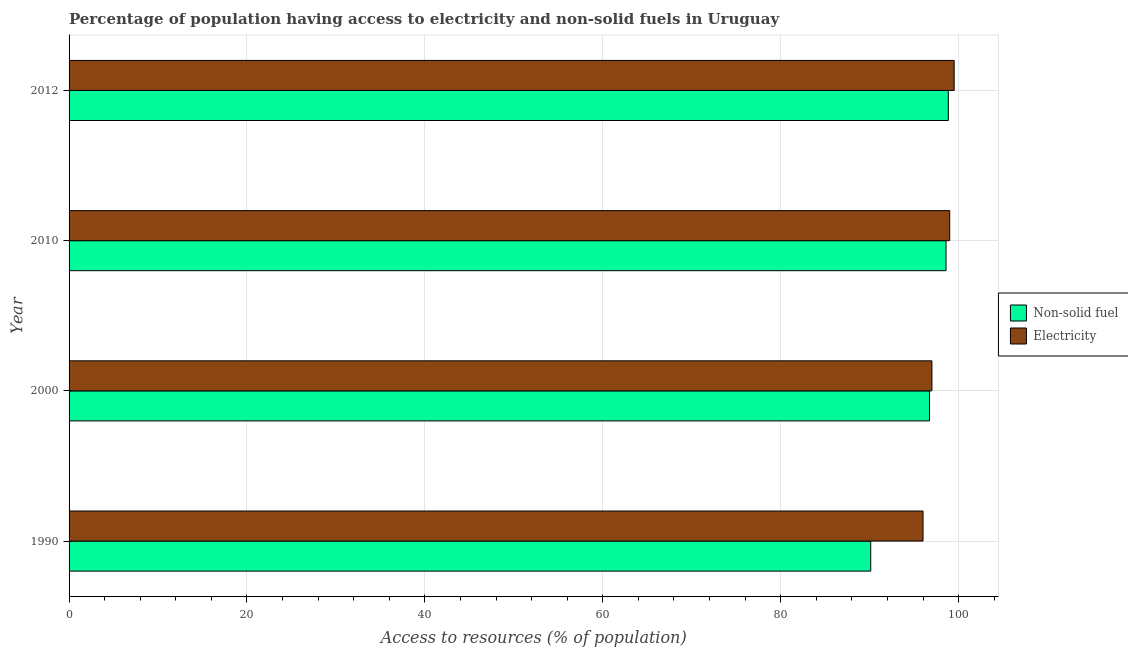How many groups of bars are there?
Ensure brevity in your answer.  4. How many bars are there on the 3rd tick from the top?
Provide a succinct answer. 2. What is the label of the 4th group of bars from the top?
Your response must be concise. 1990. What is the percentage of population having access to non-solid fuel in 2010?
Your answer should be compact. 98.59. Across all years, what is the maximum percentage of population having access to electricity?
Offer a terse response. 99.5. Across all years, what is the minimum percentage of population having access to electricity?
Keep it short and to the point. 96. In which year was the percentage of population having access to electricity minimum?
Give a very brief answer. 1990. What is the total percentage of population having access to non-solid fuel in the graph?
Provide a short and direct response. 384.29. What is the difference between the percentage of population having access to electricity in 1990 and that in 2012?
Make the answer very short. -3.5. What is the difference between the percentage of population having access to electricity in 2000 and the percentage of population having access to non-solid fuel in 2010?
Provide a succinct answer. -1.59. What is the average percentage of population having access to electricity per year?
Offer a very short reply. 97.88. In the year 2010, what is the difference between the percentage of population having access to non-solid fuel and percentage of population having access to electricity?
Ensure brevity in your answer.  -0.41. Is the difference between the percentage of population having access to non-solid fuel in 2000 and 2010 greater than the difference between the percentage of population having access to electricity in 2000 and 2010?
Offer a very short reply. Yes. What is the difference between the highest and the second highest percentage of population having access to non-solid fuel?
Ensure brevity in your answer.  0.26. What is the difference between the highest and the lowest percentage of population having access to non-solid fuel?
Keep it short and to the point. 8.72. Is the sum of the percentage of population having access to electricity in 2000 and 2010 greater than the maximum percentage of population having access to non-solid fuel across all years?
Keep it short and to the point. Yes. What does the 2nd bar from the top in 2010 represents?
Provide a short and direct response. Non-solid fuel. What does the 2nd bar from the bottom in 2010 represents?
Make the answer very short. Electricity. How many bars are there?
Give a very brief answer. 8. How many years are there in the graph?
Offer a very short reply. 4. Where does the legend appear in the graph?
Keep it short and to the point. Center right. How many legend labels are there?
Your response must be concise. 2. How are the legend labels stacked?
Your answer should be very brief. Vertical. What is the title of the graph?
Your answer should be very brief. Percentage of population having access to electricity and non-solid fuels in Uruguay. What is the label or title of the X-axis?
Your answer should be very brief. Access to resources (% of population). What is the Access to resources (% of population) of Non-solid fuel in 1990?
Provide a succinct answer. 90.12. What is the Access to resources (% of population) in Electricity in 1990?
Your answer should be compact. 96. What is the Access to resources (% of population) of Non-solid fuel in 2000?
Offer a very short reply. 96.73. What is the Access to resources (% of population) of Electricity in 2000?
Offer a very short reply. 97. What is the Access to resources (% of population) of Non-solid fuel in 2010?
Offer a terse response. 98.59. What is the Access to resources (% of population) in Electricity in 2010?
Your answer should be very brief. 99. What is the Access to resources (% of population) in Non-solid fuel in 2012?
Give a very brief answer. 98.85. What is the Access to resources (% of population) of Electricity in 2012?
Your answer should be compact. 99.5. Across all years, what is the maximum Access to resources (% of population) in Non-solid fuel?
Your answer should be compact. 98.85. Across all years, what is the maximum Access to resources (% of population) in Electricity?
Ensure brevity in your answer.  99.5. Across all years, what is the minimum Access to resources (% of population) in Non-solid fuel?
Your answer should be very brief. 90.12. Across all years, what is the minimum Access to resources (% of population) of Electricity?
Provide a succinct answer. 96. What is the total Access to resources (% of population) in Non-solid fuel in the graph?
Give a very brief answer. 384.29. What is the total Access to resources (% of population) in Electricity in the graph?
Provide a succinct answer. 391.5. What is the difference between the Access to resources (% of population) of Non-solid fuel in 1990 and that in 2000?
Your answer should be compact. -6.61. What is the difference between the Access to resources (% of population) of Non-solid fuel in 1990 and that in 2010?
Give a very brief answer. -8.46. What is the difference between the Access to resources (% of population) in Electricity in 1990 and that in 2010?
Your answer should be very brief. -3. What is the difference between the Access to resources (% of population) of Non-solid fuel in 1990 and that in 2012?
Offer a very short reply. -8.72. What is the difference between the Access to resources (% of population) in Electricity in 1990 and that in 2012?
Your answer should be compact. -3.5. What is the difference between the Access to resources (% of population) in Non-solid fuel in 2000 and that in 2010?
Keep it short and to the point. -1.85. What is the difference between the Access to resources (% of population) of Non-solid fuel in 2000 and that in 2012?
Provide a succinct answer. -2.11. What is the difference between the Access to resources (% of population) in Non-solid fuel in 2010 and that in 2012?
Your response must be concise. -0.26. What is the difference between the Access to resources (% of population) in Electricity in 2010 and that in 2012?
Make the answer very short. -0.5. What is the difference between the Access to resources (% of population) of Non-solid fuel in 1990 and the Access to resources (% of population) of Electricity in 2000?
Provide a short and direct response. -6.88. What is the difference between the Access to resources (% of population) in Non-solid fuel in 1990 and the Access to resources (% of population) in Electricity in 2010?
Your response must be concise. -8.88. What is the difference between the Access to resources (% of population) in Non-solid fuel in 1990 and the Access to resources (% of population) in Electricity in 2012?
Ensure brevity in your answer.  -9.38. What is the difference between the Access to resources (% of population) in Non-solid fuel in 2000 and the Access to resources (% of population) in Electricity in 2010?
Offer a terse response. -2.27. What is the difference between the Access to resources (% of population) of Non-solid fuel in 2000 and the Access to resources (% of population) of Electricity in 2012?
Your answer should be compact. -2.77. What is the difference between the Access to resources (% of population) in Non-solid fuel in 2010 and the Access to resources (% of population) in Electricity in 2012?
Provide a succinct answer. -0.91. What is the average Access to resources (% of population) in Non-solid fuel per year?
Your answer should be compact. 96.07. What is the average Access to resources (% of population) of Electricity per year?
Ensure brevity in your answer.  97.88. In the year 1990, what is the difference between the Access to resources (% of population) of Non-solid fuel and Access to resources (% of population) of Electricity?
Your answer should be very brief. -5.88. In the year 2000, what is the difference between the Access to resources (% of population) in Non-solid fuel and Access to resources (% of population) in Electricity?
Offer a terse response. -0.27. In the year 2010, what is the difference between the Access to resources (% of population) of Non-solid fuel and Access to resources (% of population) of Electricity?
Ensure brevity in your answer.  -0.41. In the year 2012, what is the difference between the Access to resources (% of population) of Non-solid fuel and Access to resources (% of population) of Electricity?
Your response must be concise. -0.65. What is the ratio of the Access to resources (% of population) of Non-solid fuel in 1990 to that in 2000?
Ensure brevity in your answer.  0.93. What is the ratio of the Access to resources (% of population) in Non-solid fuel in 1990 to that in 2010?
Your response must be concise. 0.91. What is the ratio of the Access to resources (% of population) in Electricity in 1990 to that in 2010?
Offer a terse response. 0.97. What is the ratio of the Access to resources (% of population) in Non-solid fuel in 1990 to that in 2012?
Offer a terse response. 0.91. What is the ratio of the Access to resources (% of population) of Electricity in 1990 to that in 2012?
Give a very brief answer. 0.96. What is the ratio of the Access to resources (% of population) in Non-solid fuel in 2000 to that in 2010?
Keep it short and to the point. 0.98. What is the ratio of the Access to resources (% of population) in Electricity in 2000 to that in 2010?
Your answer should be very brief. 0.98. What is the ratio of the Access to resources (% of population) of Non-solid fuel in 2000 to that in 2012?
Your answer should be compact. 0.98. What is the ratio of the Access to resources (% of population) of Electricity in 2000 to that in 2012?
Your answer should be compact. 0.97. What is the difference between the highest and the second highest Access to resources (% of population) of Non-solid fuel?
Provide a succinct answer. 0.26. What is the difference between the highest and the second highest Access to resources (% of population) in Electricity?
Offer a terse response. 0.5. What is the difference between the highest and the lowest Access to resources (% of population) in Non-solid fuel?
Make the answer very short. 8.72. 